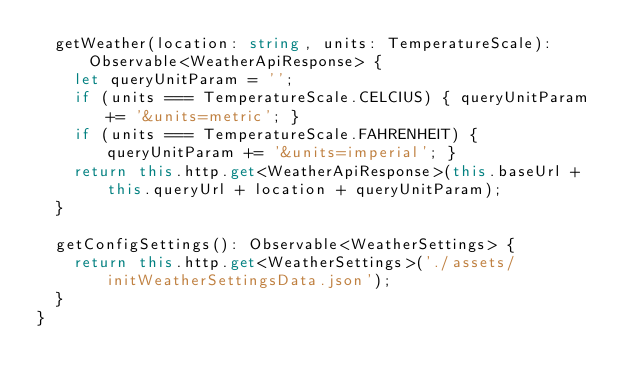Convert code to text. <code><loc_0><loc_0><loc_500><loc_500><_TypeScript_>  getWeather(location: string, units: TemperatureScale): Observable<WeatherApiResponse> {
    let queryUnitParam = '';
    if (units === TemperatureScale.CELCIUS) { queryUnitParam += '&units=metric'; }
    if (units === TemperatureScale.FAHRENHEIT) { queryUnitParam += '&units=imperial'; }
    return this.http.get<WeatherApiResponse>(this.baseUrl + this.queryUrl + location + queryUnitParam);
  }

  getConfigSettings(): Observable<WeatherSettings> {
    return this.http.get<WeatherSettings>('./assets/initWeatherSettingsData.json');
  }
}
</code> 